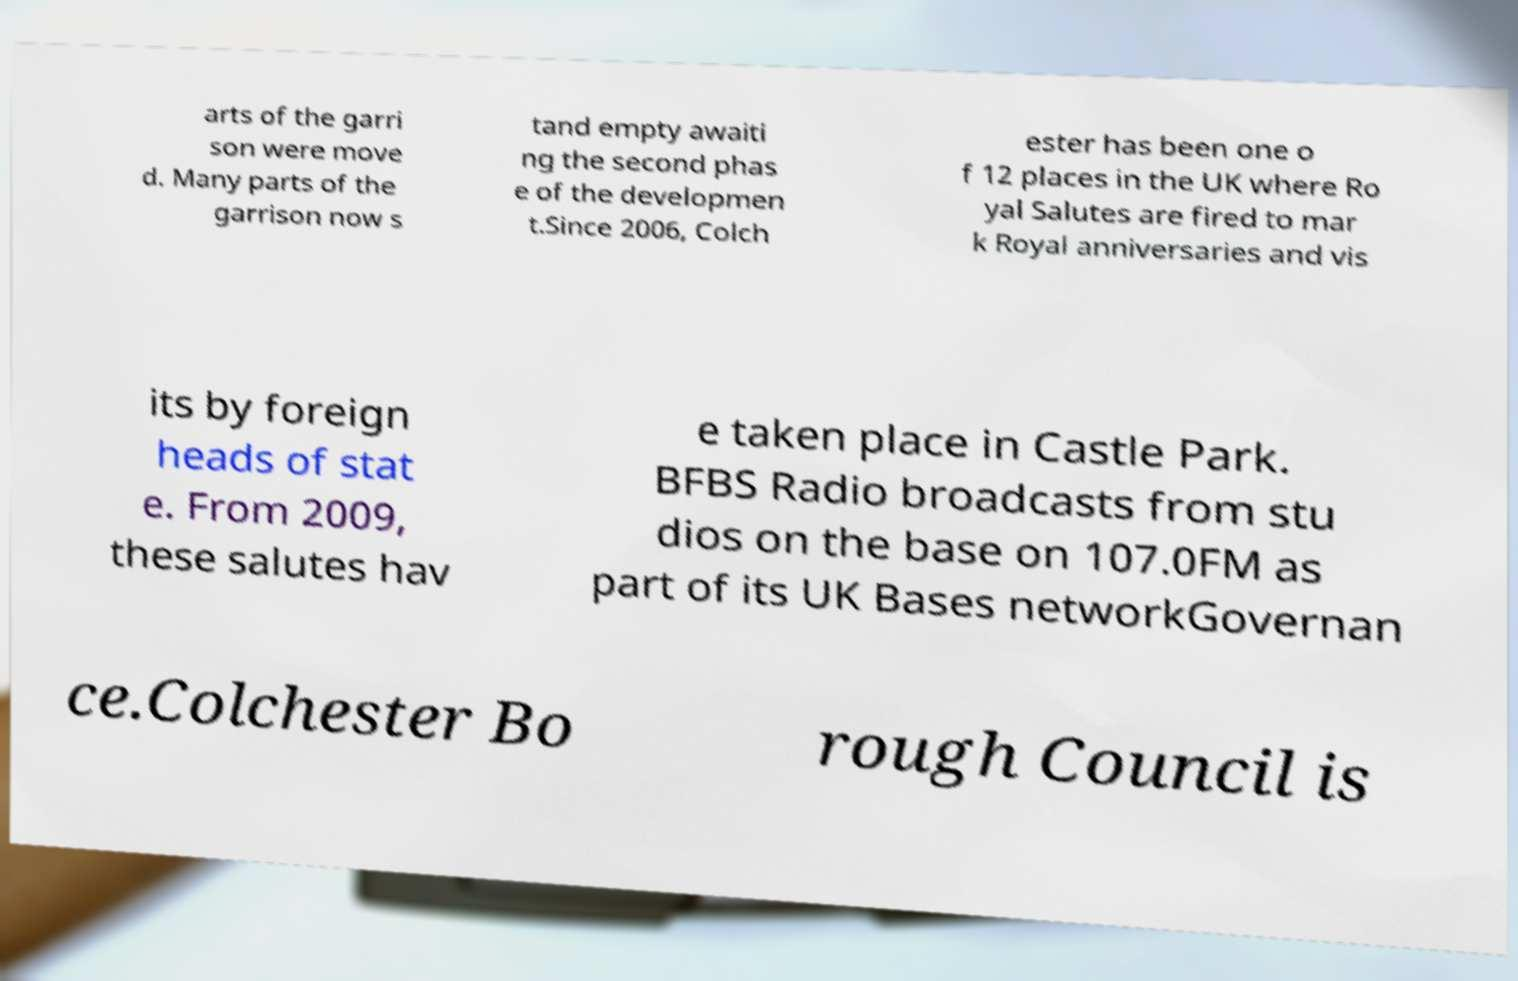What messages or text are displayed in this image? I need them in a readable, typed format. arts of the garri son were move d. Many parts of the garrison now s tand empty awaiti ng the second phas e of the developmen t.Since 2006, Colch ester has been one o f 12 places in the UK where Ro yal Salutes are fired to mar k Royal anniversaries and vis its by foreign heads of stat e. From 2009, these salutes hav e taken place in Castle Park. BFBS Radio broadcasts from stu dios on the base on 107.0FM as part of its UK Bases networkGovernan ce.Colchester Bo rough Council is 